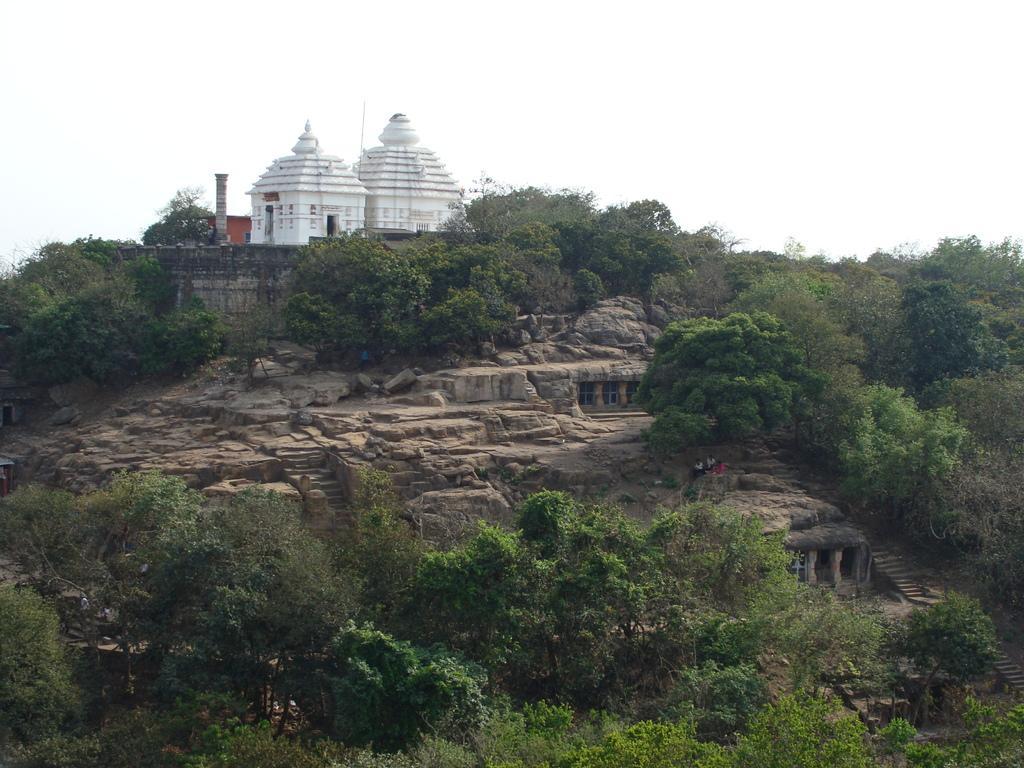In one or two sentences, can you explain what this image depicts? In this image we can see temple on the hill. In the background there is sky. 